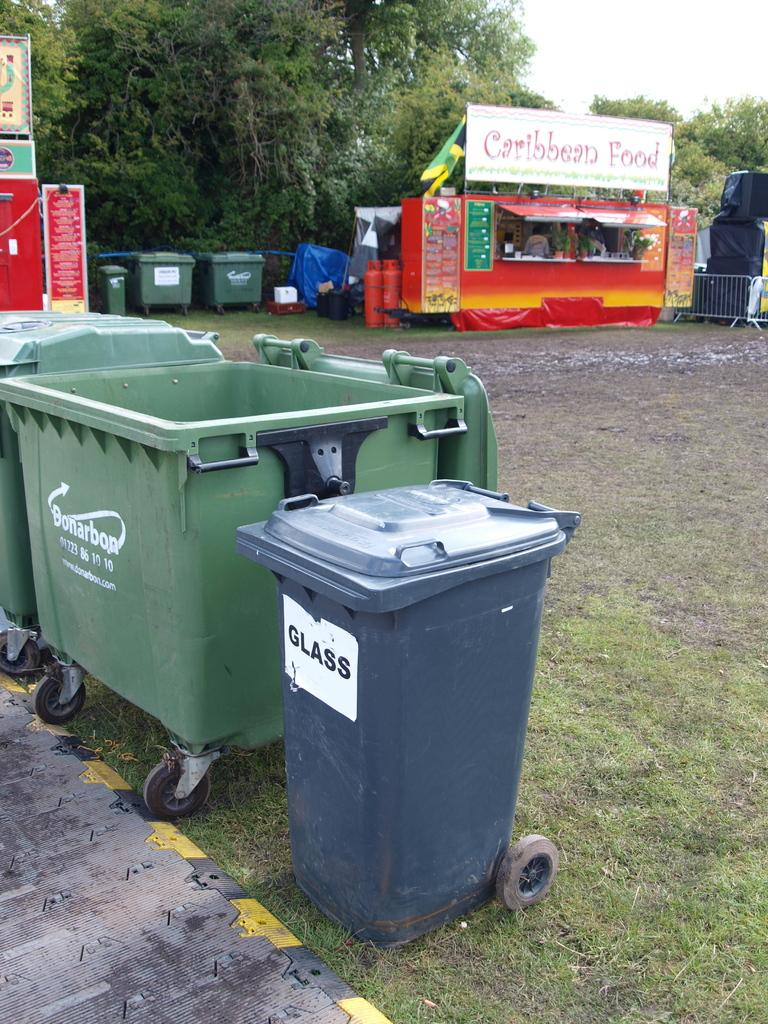<image>
Provide a brief description of the given image. Blue container which says GLASS next to a garbage can. 